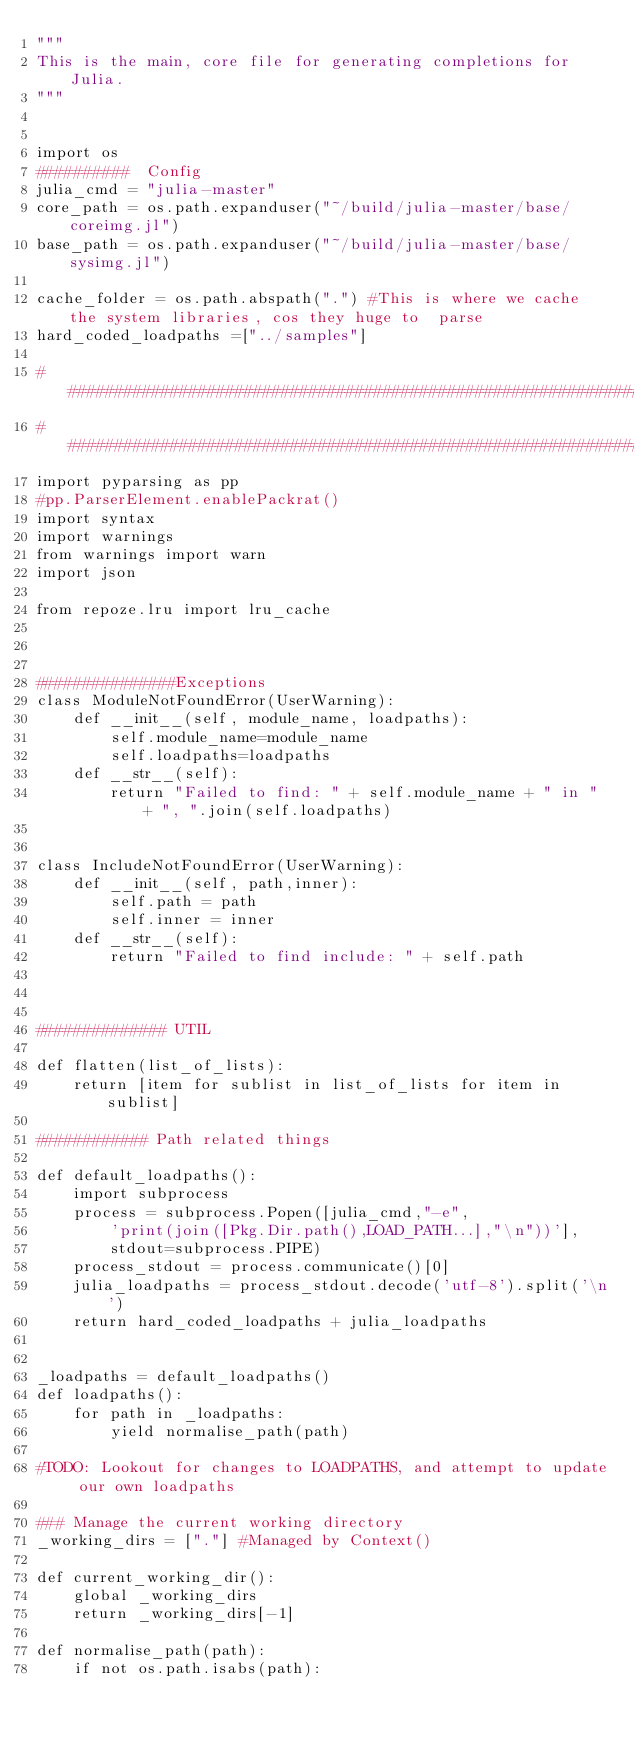Convert code to text. <code><loc_0><loc_0><loc_500><loc_500><_Python_>"""
This is the main, core file for generating completions for Julia.
"""


import os
##########  Config
julia_cmd = "julia-master"
core_path = os.path.expanduser("~/build/julia-master/base/coreimg.jl")
base_path = os.path.expanduser("~/build/julia-master/base/sysimg.jl")

cache_folder = os.path.abspath(".") #This is where we cache the system libraries, cos they huge to  parse
hard_coded_loadpaths =["../samples"]

###########################################################################################################
###########################################################################################################
import pyparsing as pp
#pp.ParserElement.enablePackrat()
import syntax
import warnings
from warnings import warn
import json

from repoze.lru import lru_cache



###############Exceptions
class ModuleNotFoundError(UserWarning):
    def __init__(self, module_name, loadpaths):
        self.module_name=module_name
        self.loadpaths=loadpaths
    def __str__(self):
        return "Failed to find: " + self.module_name + " in " + ", ".join(self.loadpaths)


class IncludeNotFoundError(UserWarning):
    def __init__(self, path,inner):
        self.path = path
        self.inner = inner
    def __str__(self):
        return "Failed to find include: " + self.path



############## UTIL

def flatten(list_of_lists):
    return [item for sublist in list_of_lists for item in sublist]

############ Path related things

def default_loadpaths():
    import subprocess
    process = subprocess.Popen([julia_cmd,"-e",
        'print(join([Pkg.Dir.path(),LOAD_PATH...],"\n"))'],
        stdout=subprocess.PIPE)
    process_stdout = process.communicate()[0]
    julia_loadpaths = process_stdout.decode('utf-8').split('\n')
    return hard_coded_loadpaths + julia_loadpaths


_loadpaths = default_loadpaths()
def loadpaths():
    for path in _loadpaths:
        yield normalise_path(path)

#TODO: Lookout for changes to LOADPATHS, and attempt to update our own loadpaths

### Manage the current working directory
_working_dirs = ["."] #Managed by Context()

def current_working_dir():
    global _working_dirs
    return _working_dirs[-1]

def normalise_path(path):
    if not os.path.isabs(path):</code> 